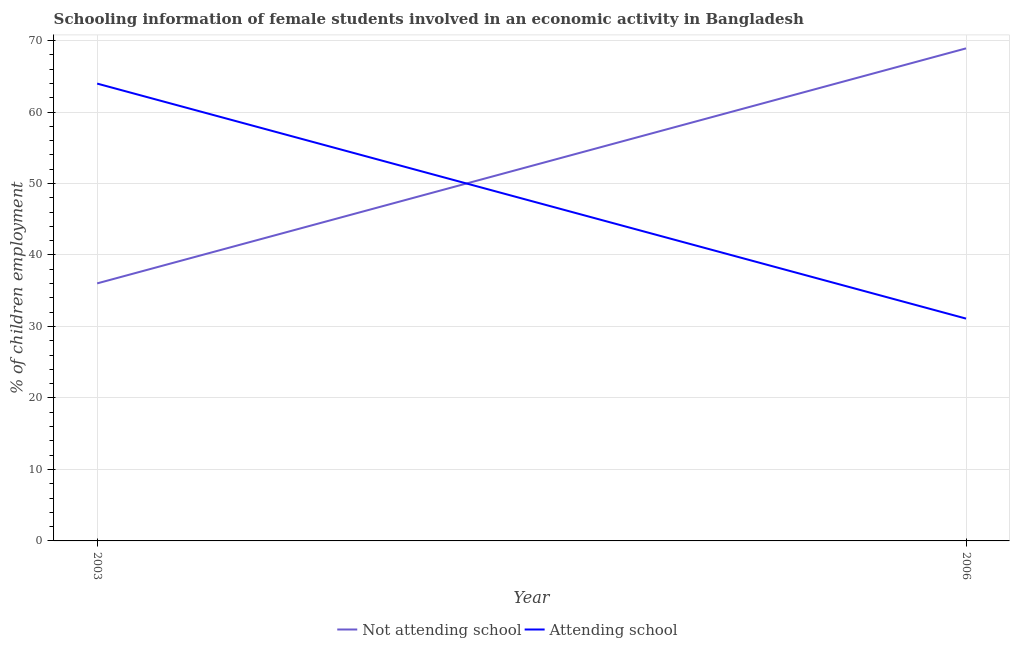Does the line corresponding to percentage of employed females who are not attending school intersect with the line corresponding to percentage of employed females who are attending school?
Your answer should be very brief. Yes. Is the number of lines equal to the number of legend labels?
Provide a short and direct response. Yes. What is the percentage of employed females who are not attending school in 2006?
Offer a very short reply. 68.9. Across all years, what is the maximum percentage of employed females who are attending school?
Your response must be concise. 63.98. Across all years, what is the minimum percentage of employed females who are attending school?
Give a very brief answer. 31.1. In which year was the percentage of employed females who are not attending school maximum?
Ensure brevity in your answer.  2006. What is the total percentage of employed females who are not attending school in the graph?
Provide a short and direct response. 104.92. What is the difference between the percentage of employed females who are attending school in 2003 and that in 2006?
Offer a very short reply. 32.88. What is the difference between the percentage of employed females who are attending school in 2006 and the percentage of employed females who are not attending school in 2003?
Your response must be concise. -4.92. What is the average percentage of employed females who are not attending school per year?
Provide a succinct answer. 52.46. In the year 2006, what is the difference between the percentage of employed females who are attending school and percentage of employed females who are not attending school?
Offer a very short reply. -37.8. In how many years, is the percentage of employed females who are not attending school greater than 30 %?
Provide a short and direct response. 2. What is the ratio of the percentage of employed females who are not attending school in 2003 to that in 2006?
Your answer should be very brief. 0.52. Is the percentage of employed females who are attending school in 2003 less than that in 2006?
Your response must be concise. No. Is the percentage of employed females who are not attending school strictly greater than the percentage of employed females who are attending school over the years?
Give a very brief answer. No. How many years are there in the graph?
Offer a terse response. 2. What is the difference between two consecutive major ticks on the Y-axis?
Give a very brief answer. 10. What is the title of the graph?
Your answer should be compact. Schooling information of female students involved in an economic activity in Bangladesh. What is the label or title of the X-axis?
Offer a very short reply. Year. What is the label or title of the Y-axis?
Your answer should be very brief. % of children employment. What is the % of children employment of Not attending school in 2003?
Ensure brevity in your answer.  36.02. What is the % of children employment of Attending school in 2003?
Give a very brief answer. 63.98. What is the % of children employment of Not attending school in 2006?
Give a very brief answer. 68.9. What is the % of children employment in Attending school in 2006?
Offer a very short reply. 31.1. Across all years, what is the maximum % of children employment of Not attending school?
Ensure brevity in your answer.  68.9. Across all years, what is the maximum % of children employment of Attending school?
Provide a short and direct response. 63.98. Across all years, what is the minimum % of children employment in Not attending school?
Offer a terse response. 36.02. Across all years, what is the minimum % of children employment in Attending school?
Ensure brevity in your answer.  31.1. What is the total % of children employment of Not attending school in the graph?
Offer a terse response. 104.92. What is the total % of children employment of Attending school in the graph?
Offer a very short reply. 95.08. What is the difference between the % of children employment of Not attending school in 2003 and that in 2006?
Give a very brief answer. -32.88. What is the difference between the % of children employment of Attending school in 2003 and that in 2006?
Provide a succinct answer. 32.88. What is the difference between the % of children employment in Not attending school in 2003 and the % of children employment in Attending school in 2006?
Your answer should be compact. 4.92. What is the average % of children employment in Not attending school per year?
Keep it short and to the point. 52.46. What is the average % of children employment of Attending school per year?
Your answer should be very brief. 47.54. In the year 2003, what is the difference between the % of children employment in Not attending school and % of children employment in Attending school?
Offer a terse response. -27.95. In the year 2006, what is the difference between the % of children employment in Not attending school and % of children employment in Attending school?
Your answer should be compact. 37.8. What is the ratio of the % of children employment of Not attending school in 2003 to that in 2006?
Your answer should be very brief. 0.52. What is the ratio of the % of children employment of Attending school in 2003 to that in 2006?
Give a very brief answer. 2.06. What is the difference between the highest and the second highest % of children employment of Not attending school?
Your answer should be very brief. 32.88. What is the difference between the highest and the second highest % of children employment of Attending school?
Ensure brevity in your answer.  32.88. What is the difference between the highest and the lowest % of children employment in Not attending school?
Provide a succinct answer. 32.88. What is the difference between the highest and the lowest % of children employment of Attending school?
Keep it short and to the point. 32.88. 